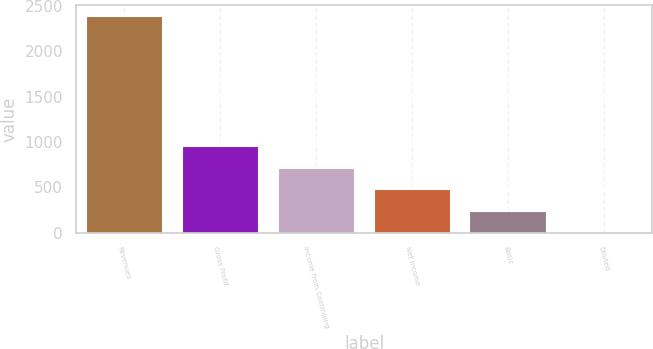<chart> <loc_0><loc_0><loc_500><loc_500><bar_chart><fcel>Revenues<fcel>Gross Profit<fcel>Income from Continuing<fcel>Net Income<fcel>Basic<fcel>Diluted<nl><fcel>2385.9<fcel>954.62<fcel>716.07<fcel>477.52<fcel>238.97<fcel>0.42<nl></chart> 